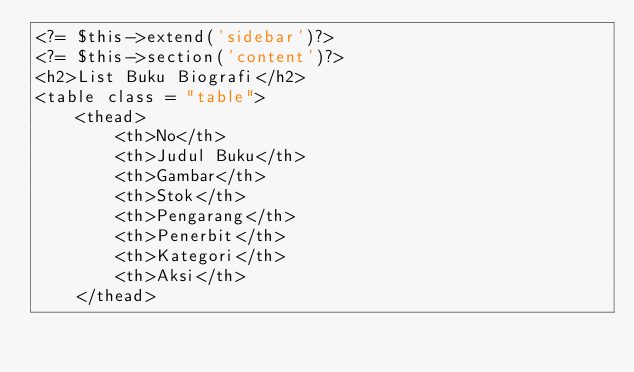<code> <loc_0><loc_0><loc_500><loc_500><_PHP_><?= $this->extend('sidebar')?>
<?= $this->section('content')?>
<h2>List Buku Biografi</h2>
<table class = "table">
    <thead>
        <th>No</th>
        <th>Judul Buku</th>
        <th>Gambar</th>
        <th>Stok</th>
        <th>Pengarang</th>
        <th>Penerbit</th>
        <th>Kategori</th>
        <th>Aksi</th>
    </thead></code> 